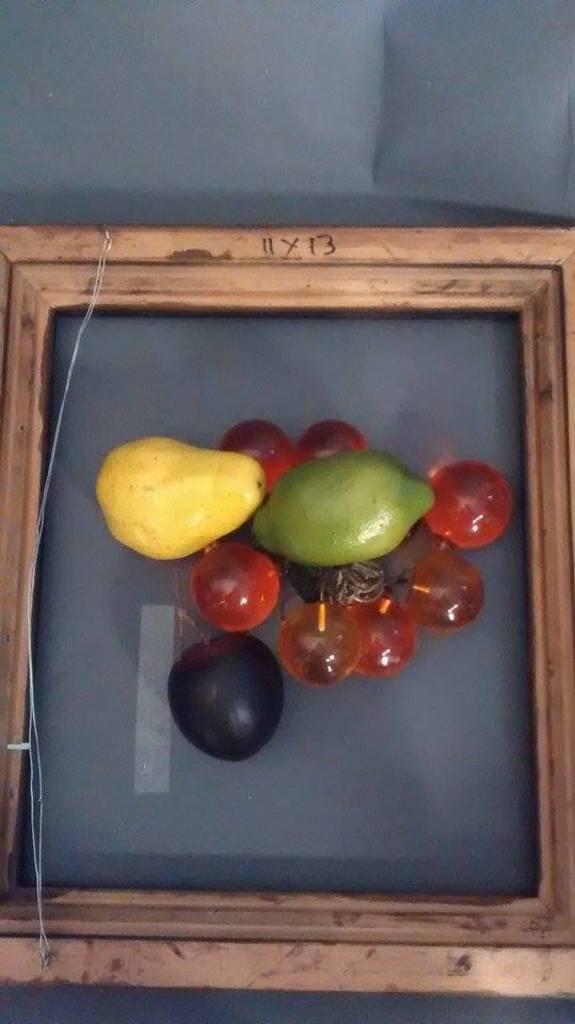In one or two sentences, can you explain what this image depicts? In this image there is a wooden frame in which there are fruits like pears,Jamun and some berries. 